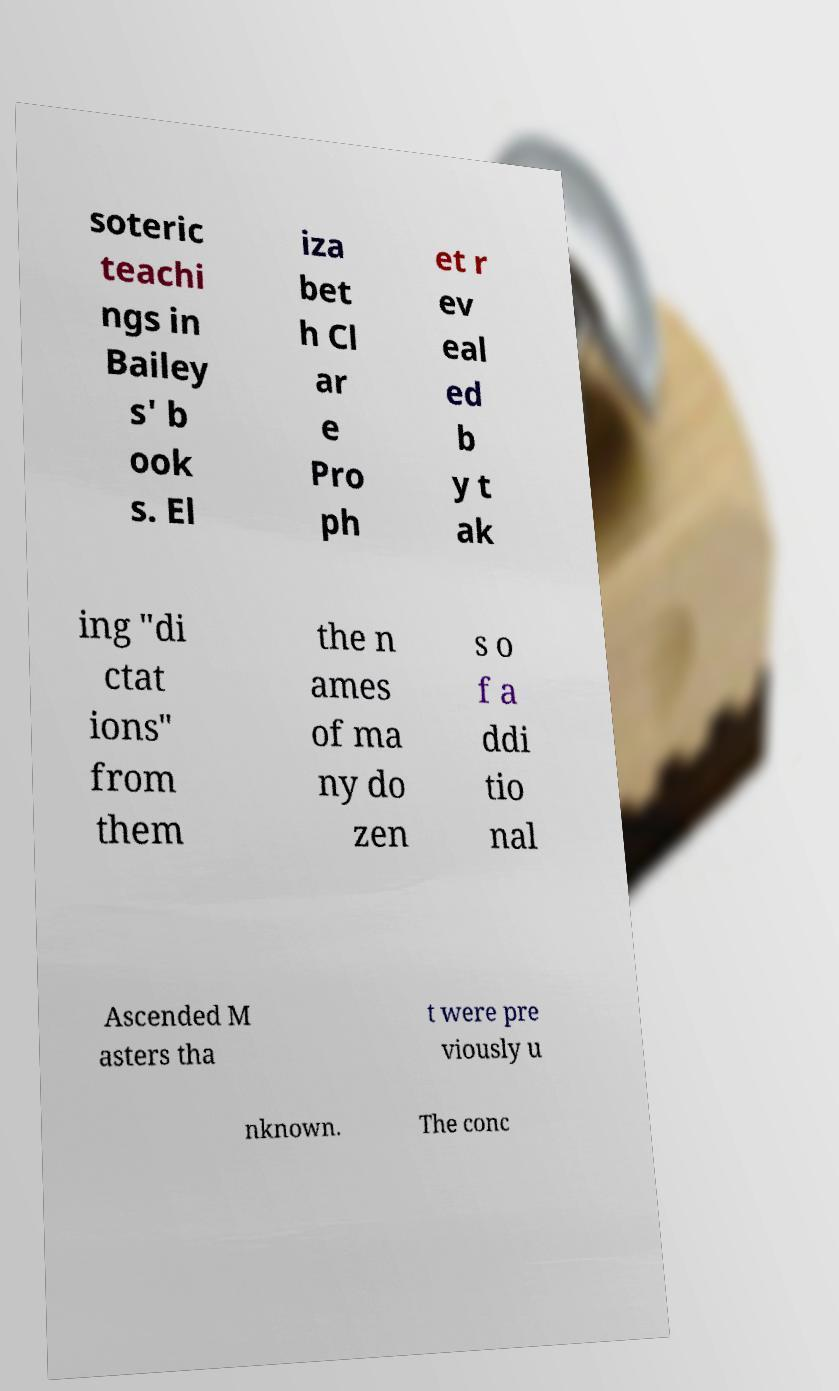Can you accurately transcribe the text from the provided image for me? soteric teachi ngs in Bailey s' b ook s. El iza bet h Cl ar e Pro ph et r ev eal ed b y t ak ing "di ctat ions" from them the n ames of ma ny do zen s o f a ddi tio nal Ascended M asters tha t were pre viously u nknown. The conc 